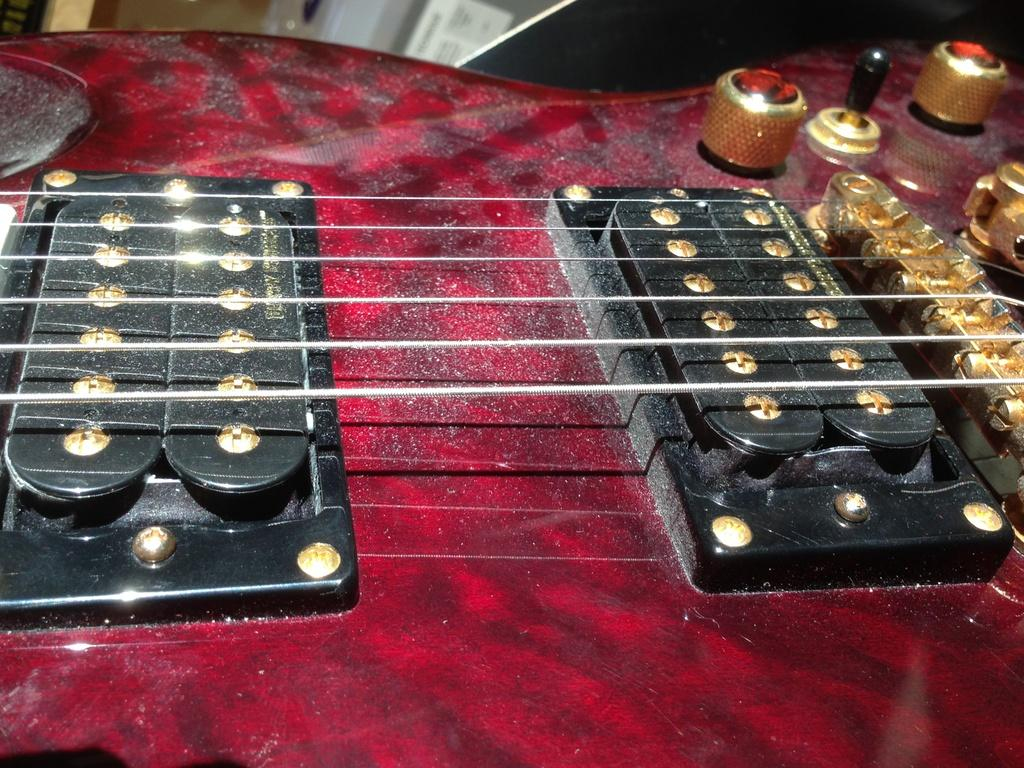What musical instrument is partially visible in the image? There is a part of a guitar in the image. What other objects can be seen at the top of the image? Unfortunately, the provided facts do not specify any other objects visible at the top of the image. How do the giants taste the guitar in the image? There are no giants present in the image, and therefore they cannot taste the guitar. 